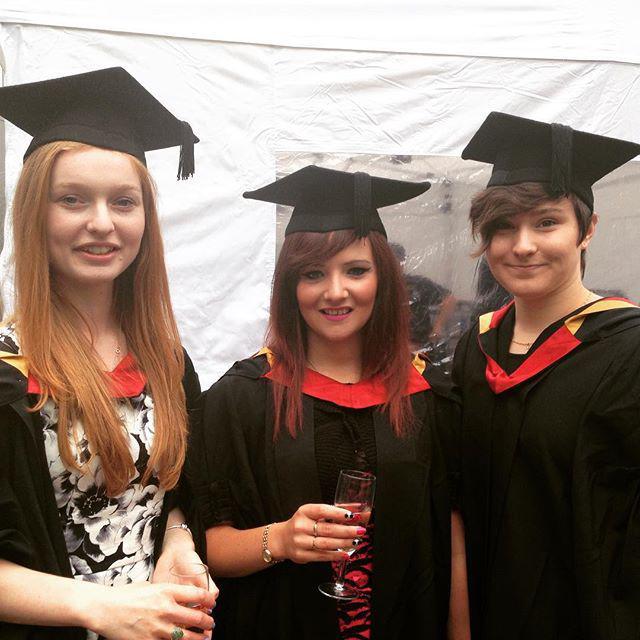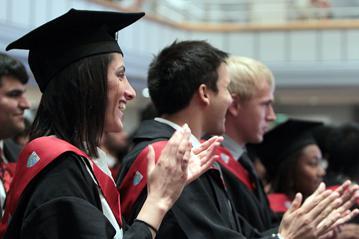The first image is the image on the left, the second image is the image on the right. Analyze the images presented: Is the assertion "An image shows three female graduates posing together wearing black grad caps." valid? Answer yes or no. Yes. 